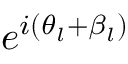Convert formula to latex. <formula><loc_0><loc_0><loc_500><loc_500>e ^ { i ( \theta _ { l } + \beta _ { l } ) }</formula> 